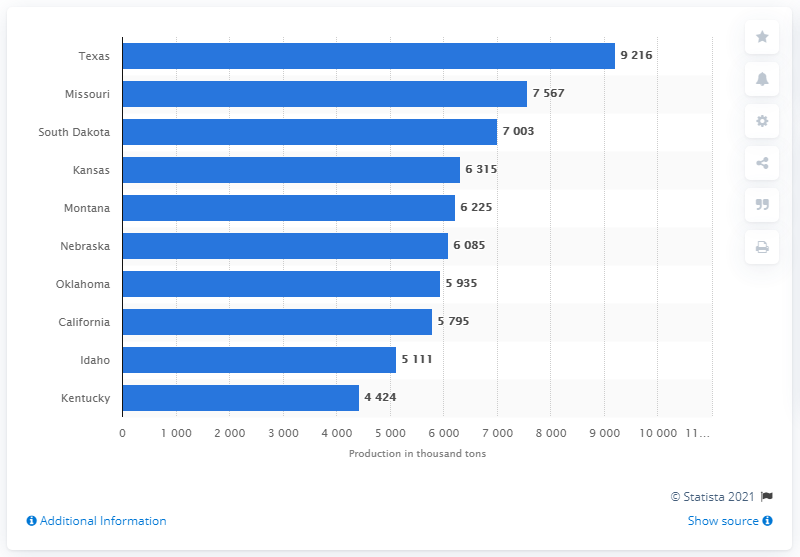Indicate a few pertinent items in this graphic. In 2019, the state of Missouri produced the most hay. 